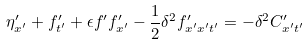<formula> <loc_0><loc_0><loc_500><loc_500>\eta ^ { \prime } _ { x ^ { \prime } } + f ^ { \prime } _ { t ^ { \prime } } + \epsilon f ^ { \prime } f ^ { \prime } _ { x ^ { \prime } } - \frac { 1 } { 2 } \delta ^ { 2 } f ^ { \prime } _ { x ^ { \prime } x ^ { \prime } t ^ { \prime } } = - \delta ^ { 2 } C ^ { \prime } _ { x ^ { \prime } t ^ { \prime } }</formula> 